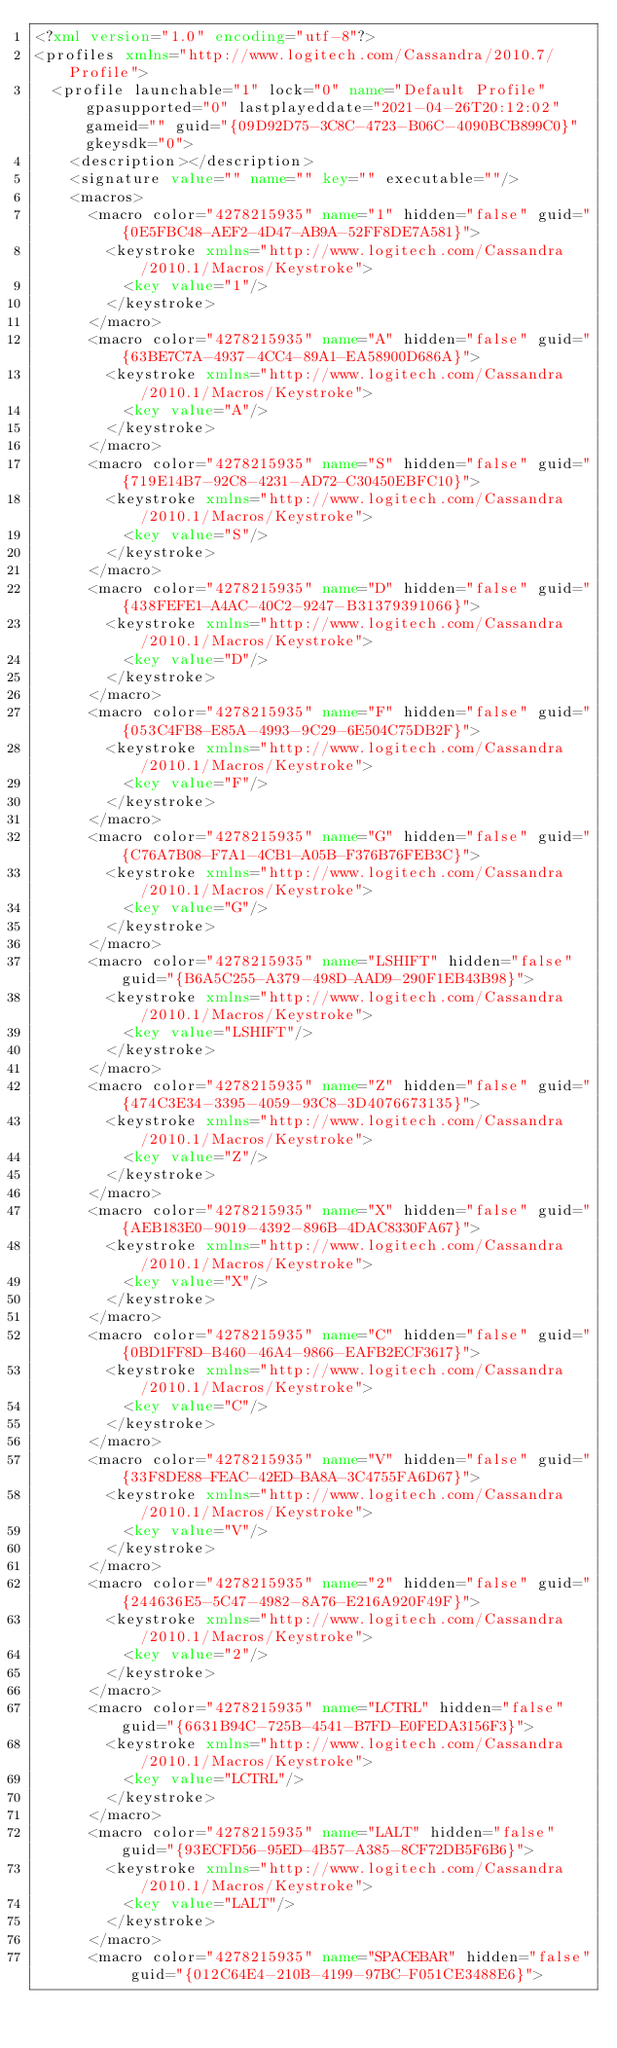<code> <loc_0><loc_0><loc_500><loc_500><_XML_><?xml version="1.0" encoding="utf-8"?>
<profiles xmlns="http://www.logitech.com/Cassandra/2010.7/Profile">
  <profile launchable="1" lock="0" name="Default Profile" gpasupported="0" lastplayeddate="2021-04-26T20:12:02" gameid="" guid="{09D92D75-3C8C-4723-B06C-4090BCB899C0}" gkeysdk="0">
    <description></description>
    <signature value="" name="" key="" executable=""/>
    <macros>
      <macro color="4278215935" name="1" hidden="false" guid="{0E5FBC48-AEF2-4D47-AB9A-52FF8DE7A581}">
        <keystroke xmlns="http://www.logitech.com/Cassandra/2010.1/Macros/Keystroke">
          <key value="1"/>
        </keystroke>
      </macro>
      <macro color="4278215935" name="A" hidden="false" guid="{63BE7C7A-4937-4CC4-89A1-EA58900D686A}">
        <keystroke xmlns="http://www.logitech.com/Cassandra/2010.1/Macros/Keystroke">
          <key value="A"/>
        </keystroke>
      </macro>
      <macro color="4278215935" name="S" hidden="false" guid="{719E14B7-92C8-4231-AD72-C30450EBFC10}">
        <keystroke xmlns="http://www.logitech.com/Cassandra/2010.1/Macros/Keystroke">
          <key value="S"/>
        </keystroke>
      </macro>
      <macro color="4278215935" name="D" hidden="false" guid="{438FEFE1-A4AC-40C2-9247-B31379391066}">
        <keystroke xmlns="http://www.logitech.com/Cassandra/2010.1/Macros/Keystroke">
          <key value="D"/>
        </keystroke>
      </macro>
      <macro color="4278215935" name="F" hidden="false" guid="{053C4FB8-E85A-4993-9C29-6E504C75DB2F}">
        <keystroke xmlns="http://www.logitech.com/Cassandra/2010.1/Macros/Keystroke">
          <key value="F"/>
        </keystroke>
      </macro>
      <macro color="4278215935" name="G" hidden="false" guid="{C76A7B08-F7A1-4CB1-A05B-F376B76FEB3C}">
        <keystroke xmlns="http://www.logitech.com/Cassandra/2010.1/Macros/Keystroke">
          <key value="G"/>
        </keystroke>
      </macro>
      <macro color="4278215935" name="LSHIFT" hidden="false" guid="{B6A5C255-A379-498D-AAD9-290F1EB43B98}">
        <keystroke xmlns="http://www.logitech.com/Cassandra/2010.1/Macros/Keystroke">
          <key value="LSHIFT"/>
        </keystroke>
      </macro>
      <macro color="4278215935" name="Z" hidden="false" guid="{474C3E34-3395-4059-93C8-3D4076673135}">
        <keystroke xmlns="http://www.logitech.com/Cassandra/2010.1/Macros/Keystroke">
          <key value="Z"/>
        </keystroke>
      </macro>
      <macro color="4278215935" name="X" hidden="false" guid="{AEB183E0-9019-4392-896B-4DAC8330FA67}">
        <keystroke xmlns="http://www.logitech.com/Cassandra/2010.1/Macros/Keystroke">
          <key value="X"/>
        </keystroke>
      </macro>
      <macro color="4278215935" name="C" hidden="false" guid="{0BD1FF8D-B460-46A4-9866-EAFB2ECF3617}">
        <keystroke xmlns="http://www.logitech.com/Cassandra/2010.1/Macros/Keystroke">
          <key value="C"/>
        </keystroke>
      </macro>
      <macro color="4278215935" name="V" hidden="false" guid="{33F8DE88-FEAC-42ED-BA8A-3C4755FA6D67}">
        <keystroke xmlns="http://www.logitech.com/Cassandra/2010.1/Macros/Keystroke">
          <key value="V"/>
        </keystroke>
      </macro>
      <macro color="4278215935" name="2" hidden="false" guid="{244636E5-5C47-4982-8A76-E216A920F49F}">
        <keystroke xmlns="http://www.logitech.com/Cassandra/2010.1/Macros/Keystroke">
          <key value="2"/>
        </keystroke>
      </macro>
      <macro color="4278215935" name="LCTRL" hidden="false" guid="{6631B94C-725B-4541-B7FD-E0FEDA3156F3}">
        <keystroke xmlns="http://www.logitech.com/Cassandra/2010.1/Macros/Keystroke">
          <key value="LCTRL"/>
        </keystroke>
      </macro>
      <macro color="4278215935" name="LALT" hidden="false" guid="{93ECFD56-95ED-4B57-A385-8CF72DB5F6B6}">
        <keystroke xmlns="http://www.logitech.com/Cassandra/2010.1/Macros/Keystroke">
          <key value="LALT"/>
        </keystroke>
      </macro>
      <macro color="4278215935" name="SPACEBAR" hidden="false" guid="{012C64E4-210B-4199-97BC-F051CE3488E6}"></code> 